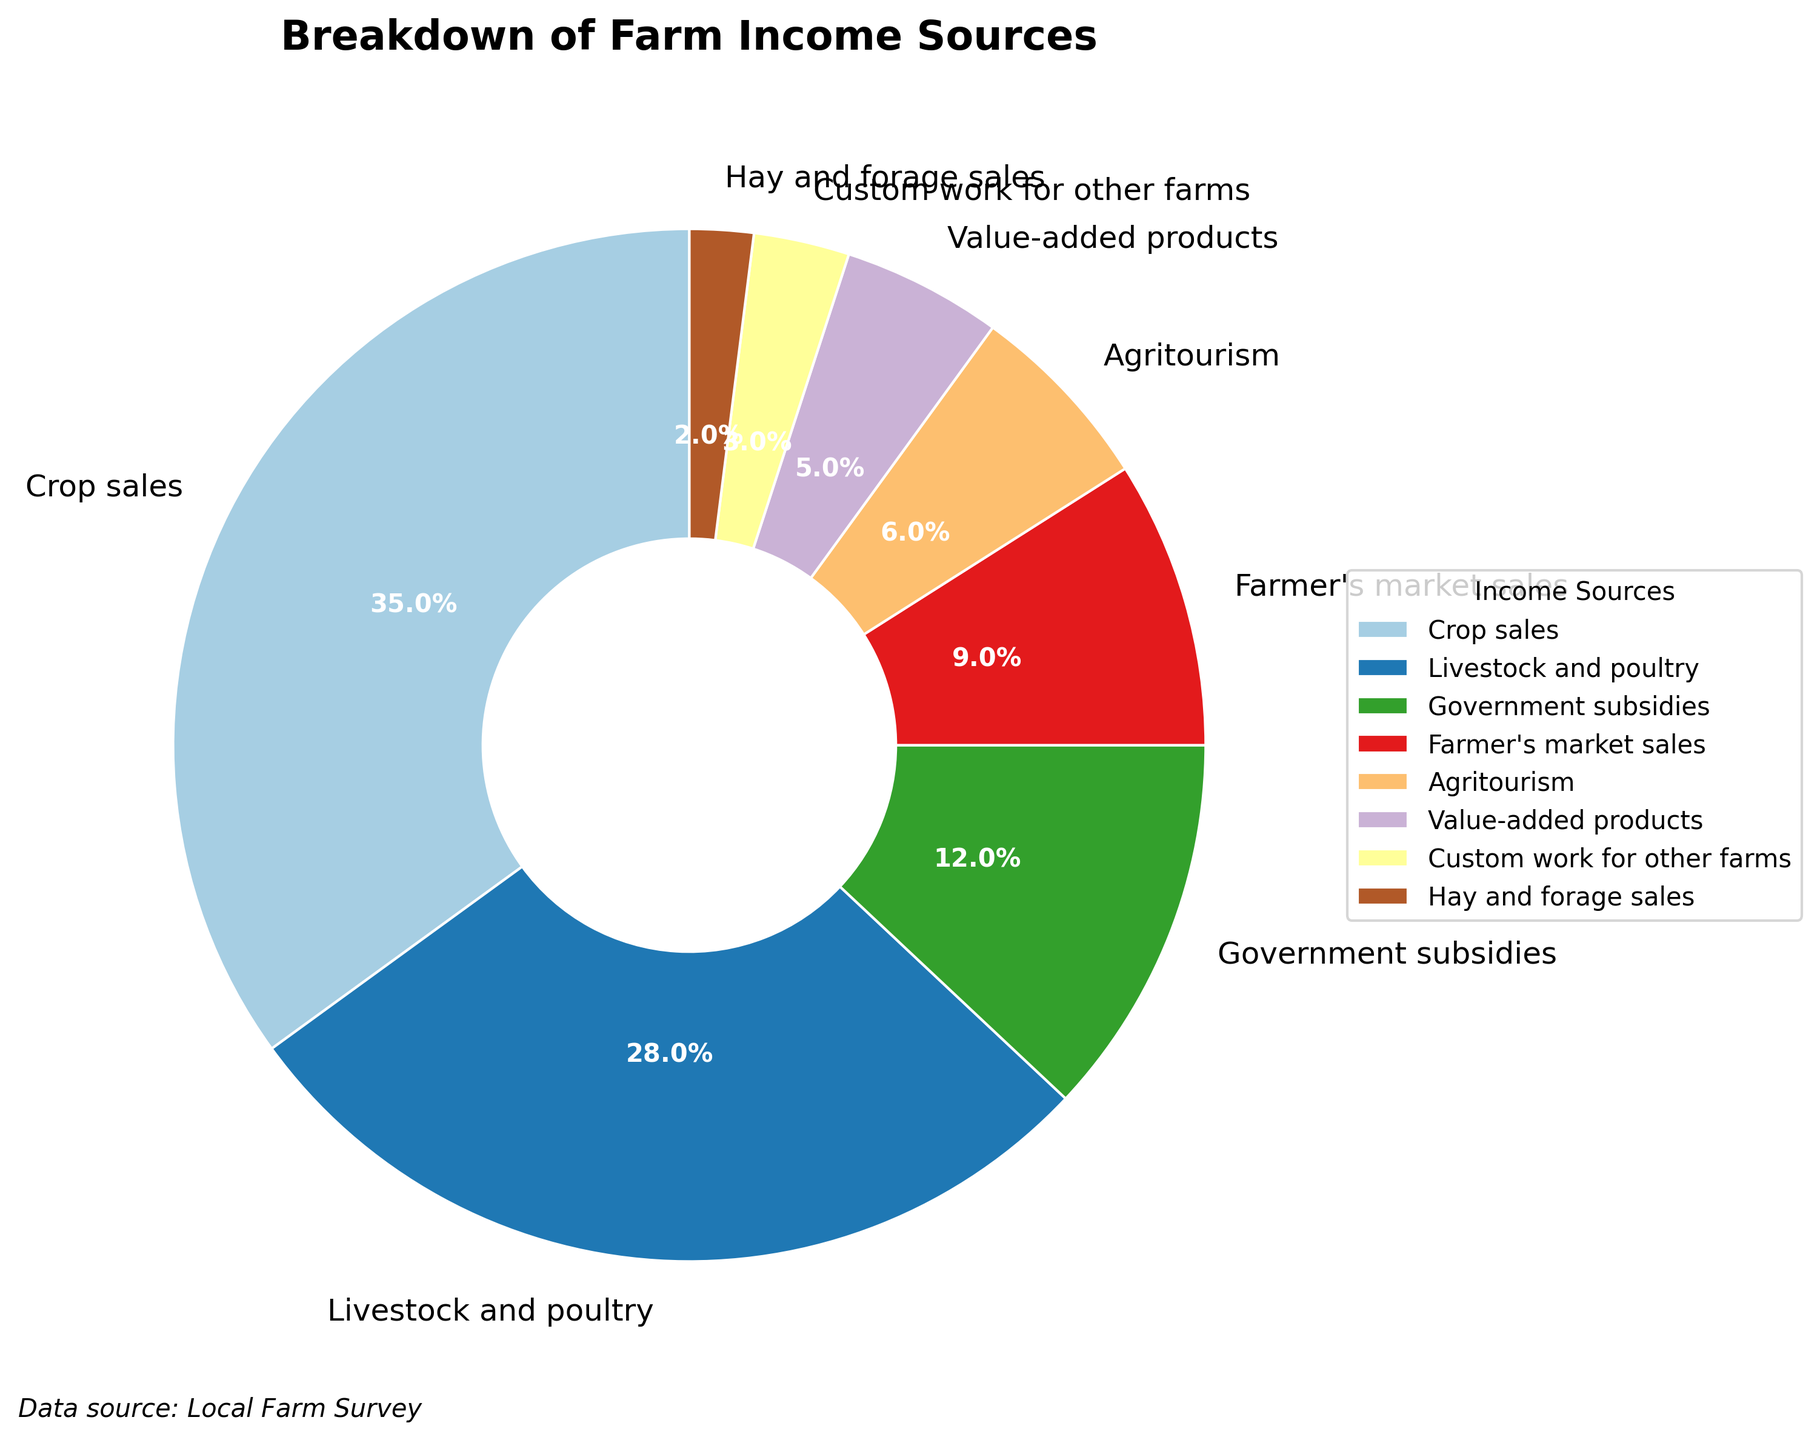What percentage of the farm's income comes from Agritourism? Look at the pie chart section labeled "Agritourism" and note the percentage associated with it.
Answer: 6% Which income source contributes the most to the farm's income? Identify the largest sector in the pie chart. Crop sales, with 35%, is the largest.
Answer: Crop sales What is the combined income percentage from Livestock and Value-added products? Add the percentages of "Livestock and poultry" (28%) and "Value-added products" (5%). 28% + 5% = 33%
Answer: 33% Is the income from Custom work for other farms greater than or less than the income from Hay and forage sales? Compare the percentage of "Custom work for other farms" (3%) with "Hay and forage sales" (2%). 3% > 2%, so it is greater.
Answer: Greater How does the percentage of income from Government subsidies compare to Farmer's market sales? Compare the percentage of "Government subsidies" (12%) to "Farmer's market sales" (9%). 12% > 9%, so it is greater.
Answer: Greater Which two income categories together make up a quarter of the total income? Look for two categories whose sums equal approximately 25%. "Livestock and poultry" (28%) and "Custom work for other farms" (3%) sum up to 31%, which is close but overshoots. "Government subsidies" (12%) and "Farmer's market sales" (9%) sum up to 21%, which is closer to the target but still off. "Agritourism" (6%) and "Farmer's market sales" (9%) sum up to 15%, while "Value-added products" (5%) and "Farmer's market sales" (9%) give 14%. Hence, adding "Hay and forage sales" (2%) to "Agritourism" (6%) gives 8%, and so on until "Crop sales" (35%) and "Hay and forage sales" (2%) provide a combined total near a major section. Thus, a more definitive solution would be a different categorical sum close to the quarter value.
Answer: None are exactly a quarter Which source of income is represented by a color closer to green? Look at the color sections and identify the segment with a color approaching green. The specific colors vary, but this helps in reviewing visually via plot aid.
Answer: Livestock and poultry (visual estimate since precise color coding varies) What fraction of the income does Government subsidies and Crop sales together form? Add the portions of "Government subsidies" (12%) and "Crop sales" (35%), amounts summing 12% + 35% = 47%. In fractional terms, this is 47/100 or simplified as 'less than half'. Mainly, two portions informed upon section's sum approach pie grid (input directly).
Answer: 47% What’s the percentage difference between the highest and the lowest income sources? Subtract the percentage of the smallest segment "Hay and forage sales" (2%) from the largest segment "Crop sales" (35%). 35% - 2% = 33%.
Answer: 33% How many sources contribute less than 10% each to the total income? Identify and count sections below 10%. These include sections “Agritourism” (6%), “Value-added products” (5%), “Custom work for other farms” (3%), and “Hay and forage sales” (2%). Summing up to 4 sources contributing singly below the threshold.
Answer: 4 sources 